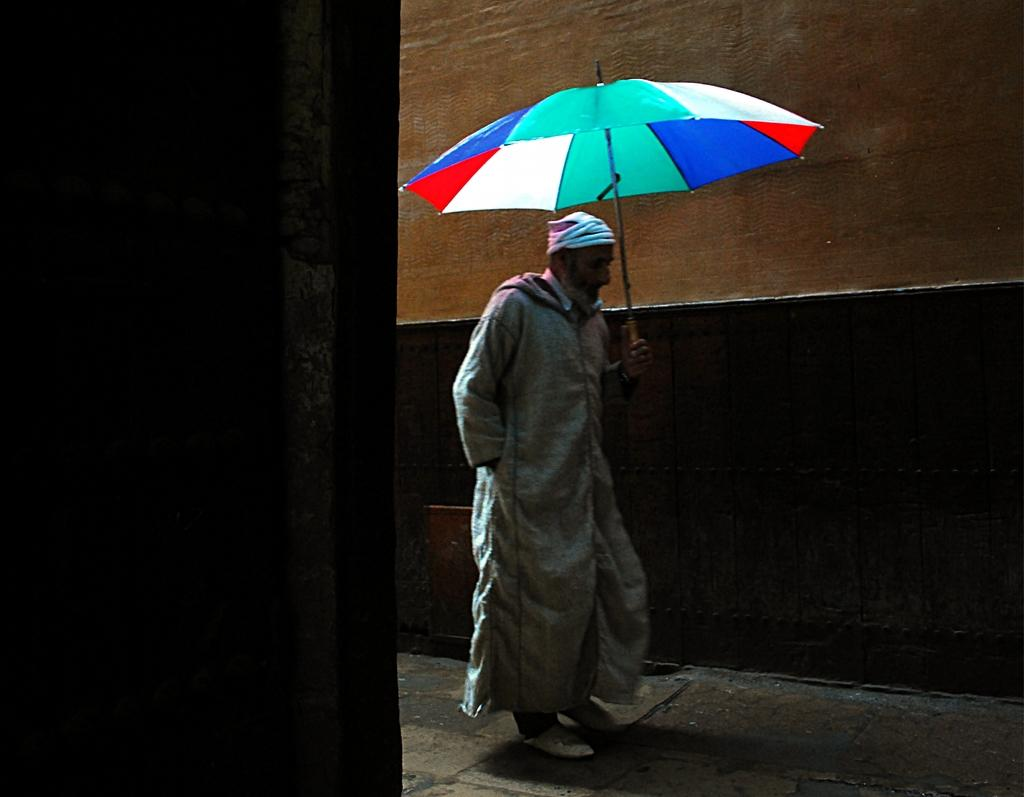Who is present in the image? There is a man in the image. What is the man doing in the image? The man is walking on the road in the image. What is the man holding in the image? The man is holding an umbrella in the image. What can be seen in the background of the image? There is a wall in the background of the image. What is the man using to talk to the wall in the image? There is no indication in the image that the man is talking to the wall, nor is there any object mentioned that could be used for talking. 